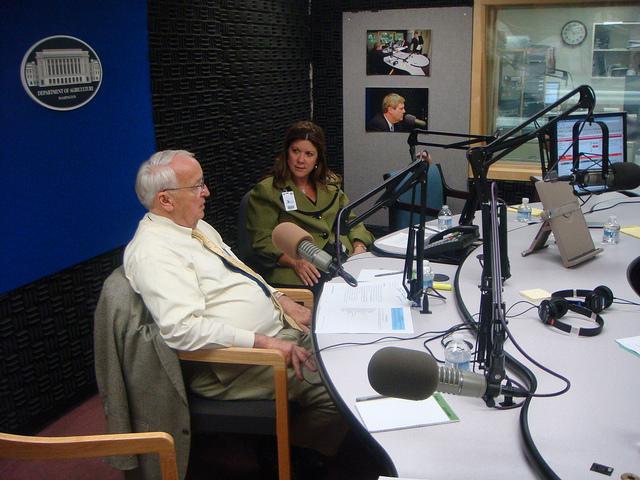What color is the man's tie?
Give a very brief answer. Yellow. How many microphones are visible?
Give a very brief answer. 4. How many bottled waters are there on the table?
Concise answer only. 5. 